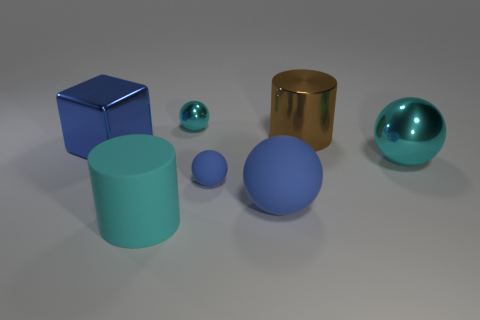Subtract 1 balls. How many balls are left? 3 Add 3 large metallic objects. How many objects exist? 10 Subtract all cylinders. How many objects are left? 5 Add 7 large cyan metal objects. How many large cyan metal objects are left? 8 Add 3 blue blocks. How many blue blocks exist? 4 Subtract 0 gray spheres. How many objects are left? 7 Subtract all big metallic cubes. Subtract all cyan rubber cylinders. How many objects are left? 5 